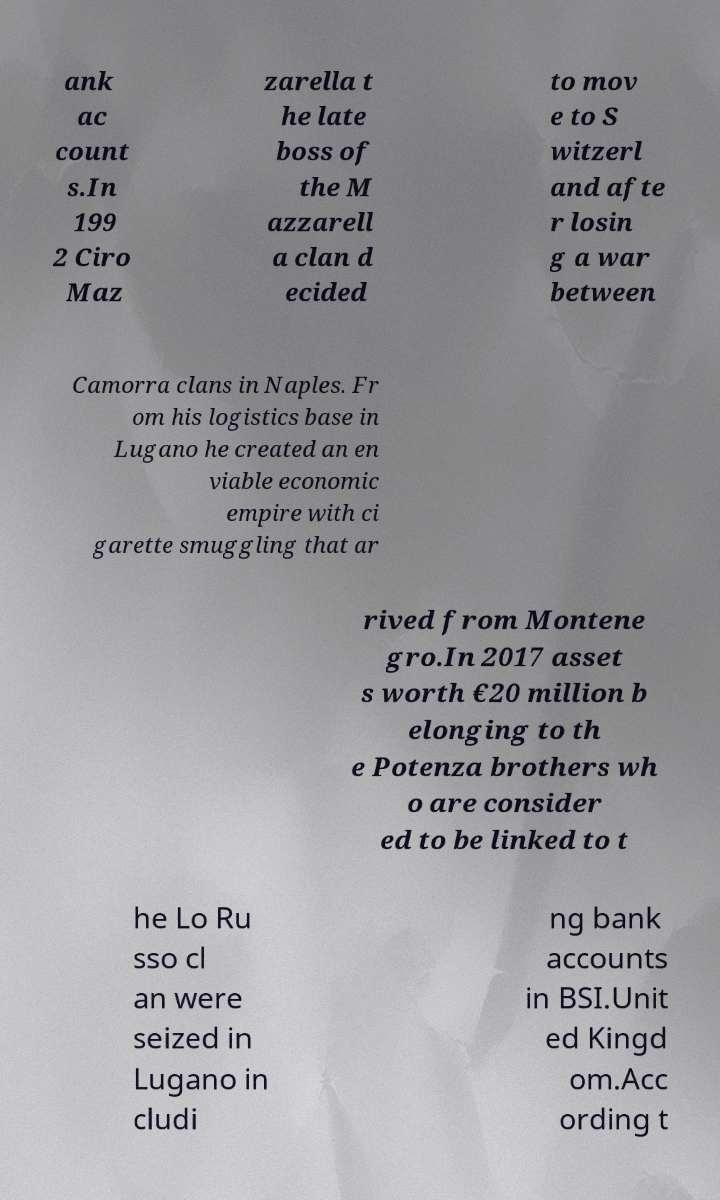Please identify and transcribe the text found in this image. ank ac count s.In 199 2 Ciro Maz zarella t he late boss of the M azzarell a clan d ecided to mov e to S witzerl and afte r losin g a war between Camorra clans in Naples. Fr om his logistics base in Lugano he created an en viable economic empire with ci garette smuggling that ar rived from Montene gro.In 2017 asset s worth €20 million b elonging to th e Potenza brothers wh o are consider ed to be linked to t he Lo Ru sso cl an were seized in Lugano in cludi ng bank accounts in BSI.Unit ed Kingd om.Acc ording t 